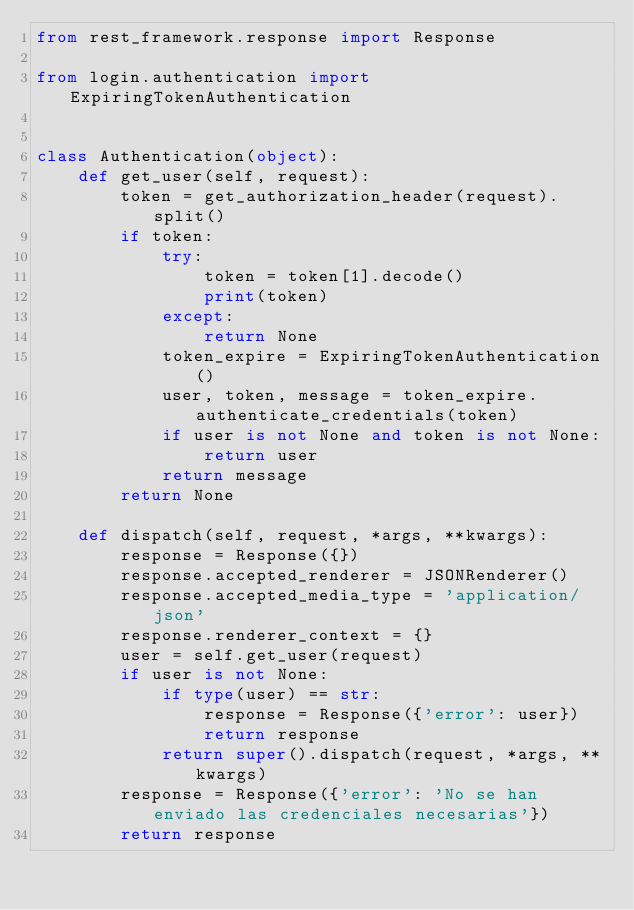<code> <loc_0><loc_0><loc_500><loc_500><_Python_>from rest_framework.response import Response

from login.authentication import ExpiringTokenAuthentication


class Authentication(object):
    def get_user(self, request):
        token = get_authorization_header(request).split()
        if token:
            try:
                token = token[1].decode()
                print(token)
            except:
                return None
            token_expire = ExpiringTokenAuthentication()
            user, token, message = token_expire.authenticate_credentials(token)
            if user is not None and token is not None:
                return user
            return message
        return None

    def dispatch(self, request, *args, **kwargs):
        response = Response({})
        response.accepted_renderer = JSONRenderer()
        response.accepted_media_type = 'application/json'
        response.renderer_context = {}
        user = self.get_user(request)
        if user is not None:
            if type(user) == str:
                response = Response({'error': user})
                return response
            return super().dispatch(request, *args, **kwargs)
        response = Response({'error': 'No se han enviado las credenciales necesarias'})
        return response
</code> 